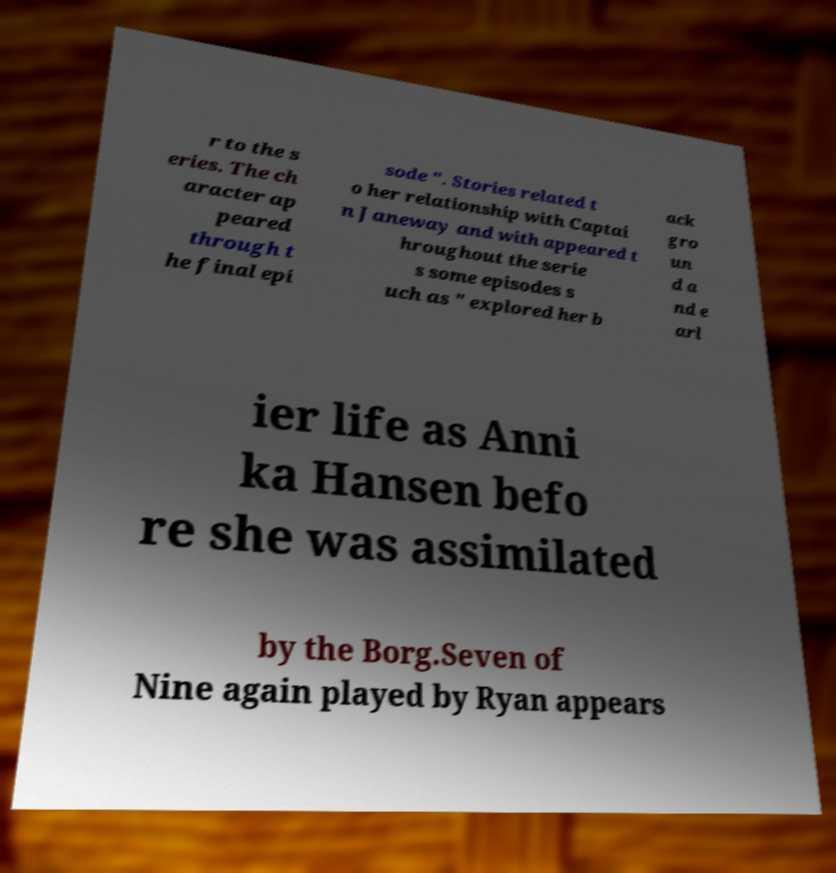What messages or text are displayed in this image? I need them in a readable, typed format. r to the s eries. The ch aracter ap peared through t he final epi sode ". Stories related t o her relationship with Captai n Janeway and with appeared t hroughout the serie s some episodes s uch as " explored her b ack gro un d a nd e arl ier life as Anni ka Hansen befo re she was assimilated by the Borg.Seven of Nine again played by Ryan appears 